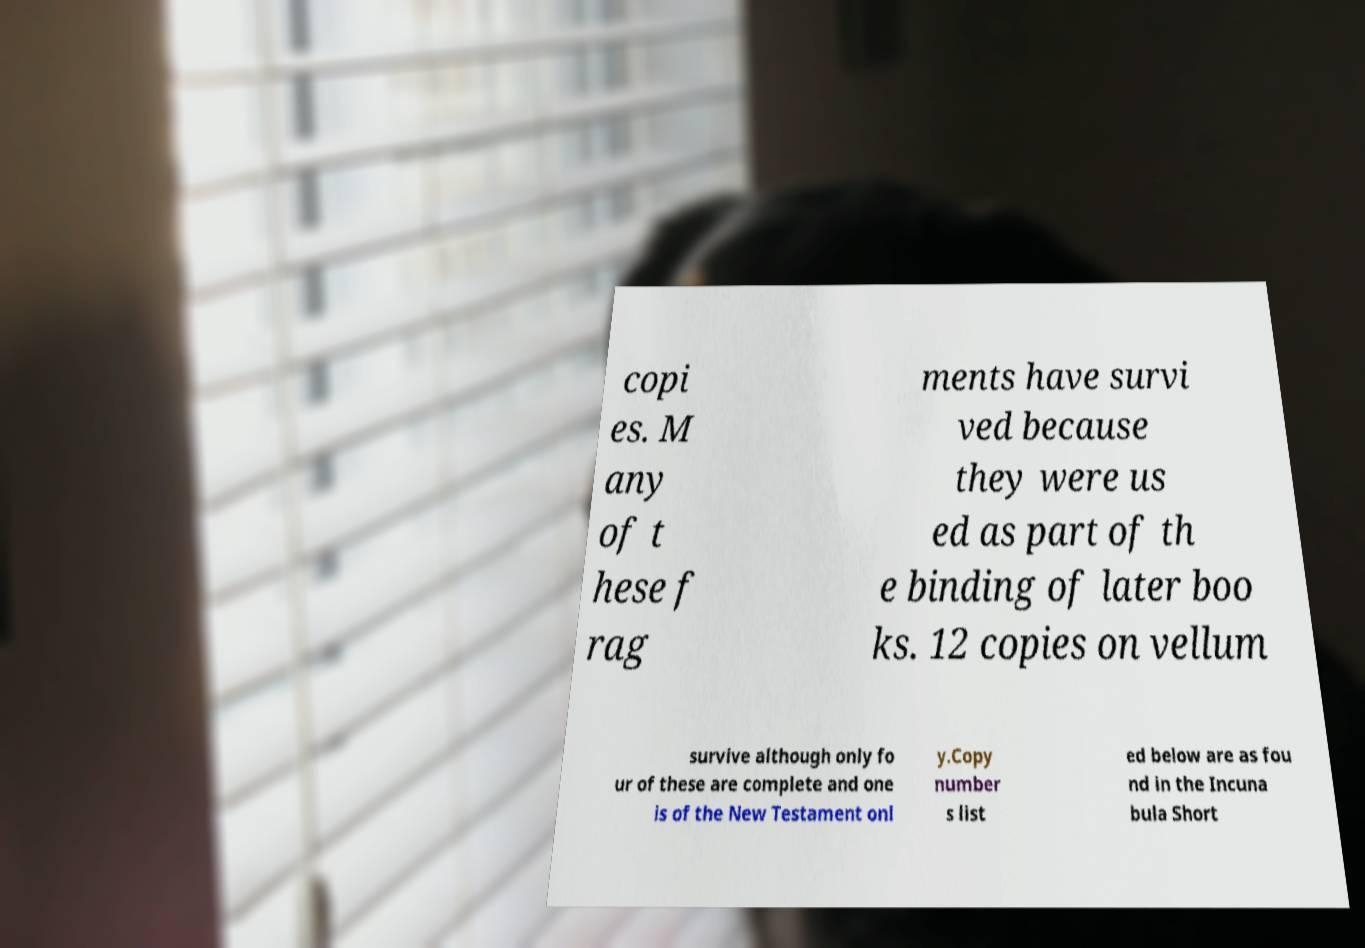Please read and relay the text visible in this image. What does it say? copi es. M any of t hese f rag ments have survi ved because they were us ed as part of th e binding of later boo ks. 12 copies on vellum survive although only fo ur of these are complete and one is of the New Testament onl y.Copy number s list ed below are as fou nd in the Incuna bula Short 